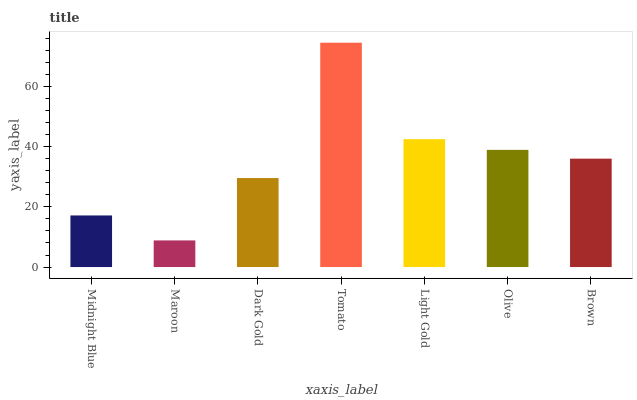Is Maroon the minimum?
Answer yes or no. Yes. Is Tomato the maximum?
Answer yes or no. Yes. Is Dark Gold the minimum?
Answer yes or no. No. Is Dark Gold the maximum?
Answer yes or no. No. Is Dark Gold greater than Maroon?
Answer yes or no. Yes. Is Maroon less than Dark Gold?
Answer yes or no. Yes. Is Maroon greater than Dark Gold?
Answer yes or no. No. Is Dark Gold less than Maroon?
Answer yes or no. No. Is Brown the high median?
Answer yes or no. Yes. Is Brown the low median?
Answer yes or no. Yes. Is Maroon the high median?
Answer yes or no. No. Is Olive the low median?
Answer yes or no. No. 